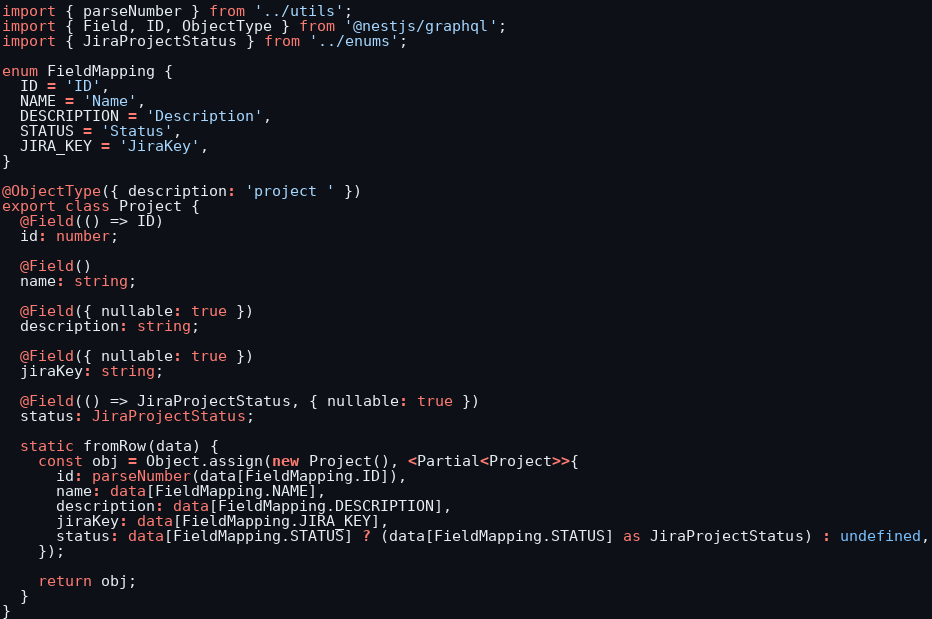Convert code to text. <code><loc_0><loc_0><loc_500><loc_500><_TypeScript_>import { parseNumber } from '../utils';
import { Field, ID, ObjectType } from '@nestjs/graphql';
import { JiraProjectStatus } from '../enums';

enum FieldMapping {
  ID = 'ID',
  NAME = 'Name',
  DESCRIPTION = 'Description',
  STATUS = 'Status',
  JIRA_KEY = 'JiraKey',
}

@ObjectType({ description: 'project ' })
export class Project {
  @Field(() => ID)
  id: number;

  @Field()
  name: string;

  @Field({ nullable: true })
  description: string;

  @Field({ nullable: true })
  jiraKey: string;

  @Field(() => JiraProjectStatus, { nullable: true })
  status: JiraProjectStatus;

  static fromRow(data) {
    const obj = Object.assign(new Project(), <Partial<Project>>{
      id: parseNumber(data[FieldMapping.ID]),
      name: data[FieldMapping.NAME],
      description: data[FieldMapping.DESCRIPTION],
      jiraKey: data[FieldMapping.JIRA_KEY],
      status: data[FieldMapping.STATUS] ? (data[FieldMapping.STATUS] as JiraProjectStatus) : undefined,
    });

    return obj;
  }
}
</code> 